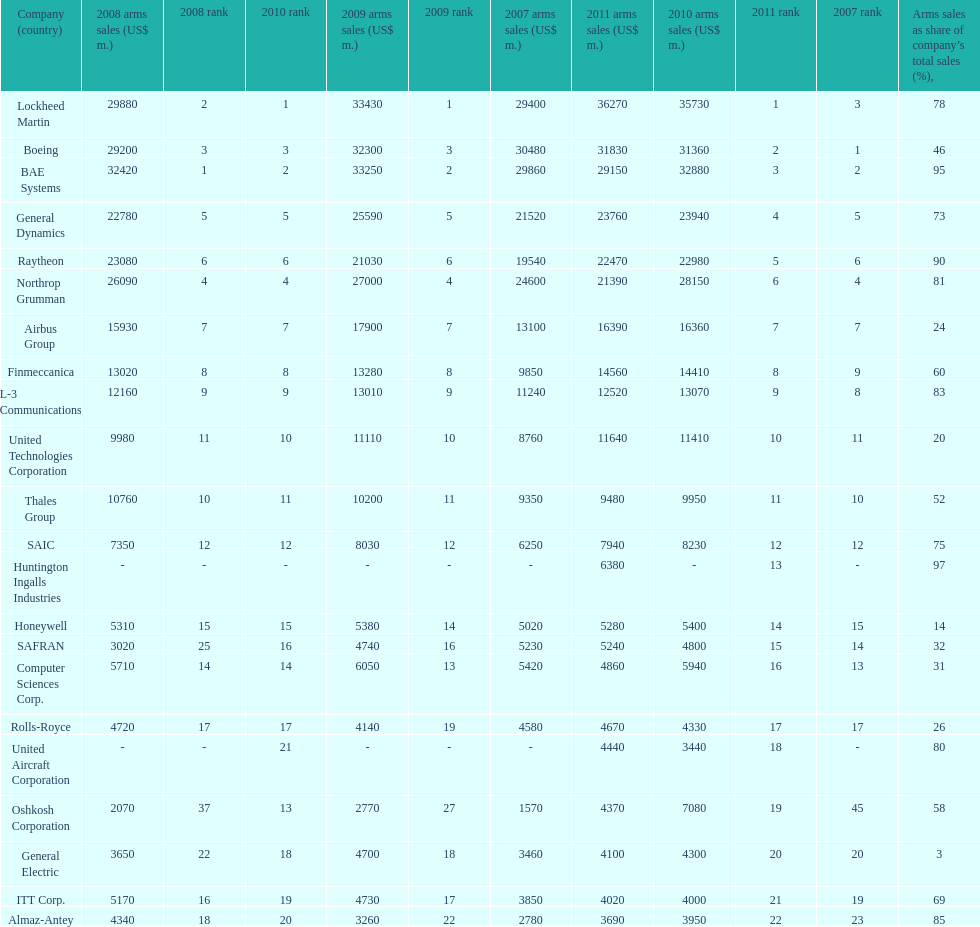What is the difference of the amount sold between boeing and general dynamics in 2007? 8960. 